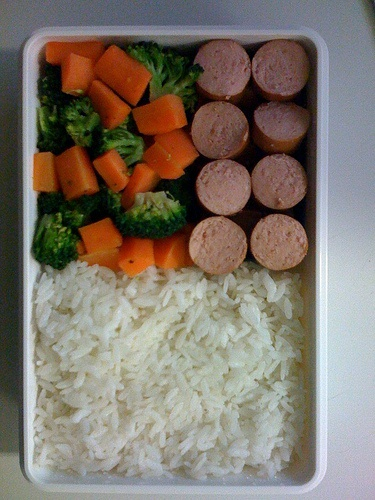Describe the objects in this image and their specific colors. I can see broccoli in gray, black, darkgreen, and maroon tones, broccoli in gray, black, darkgreen, and maroon tones, hot dog in gray, tan, and brown tones, hot dog in gray, brown, black, and maroon tones, and broccoli in gray, black, and darkgreen tones in this image. 